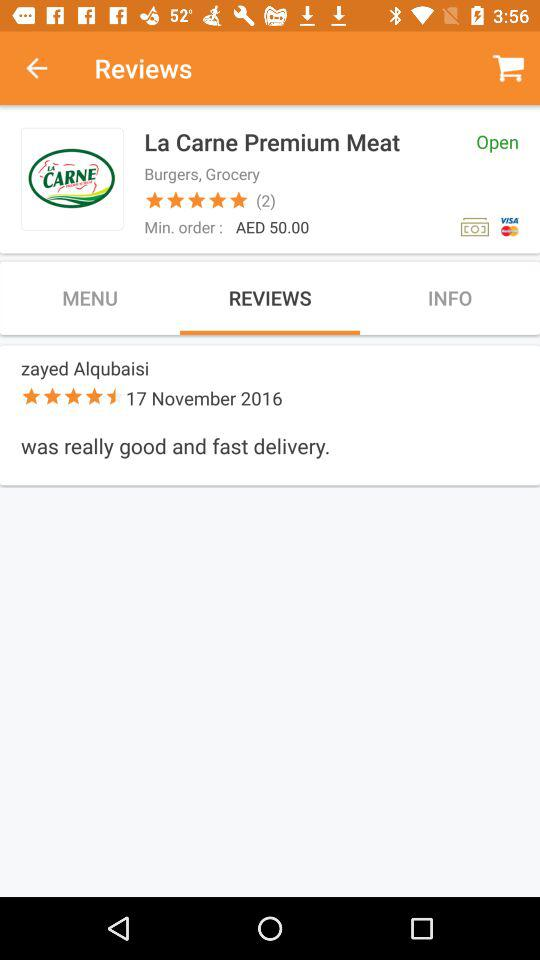How much is the minimum order?
Answer the question using a single word or phrase. AED 50.00 